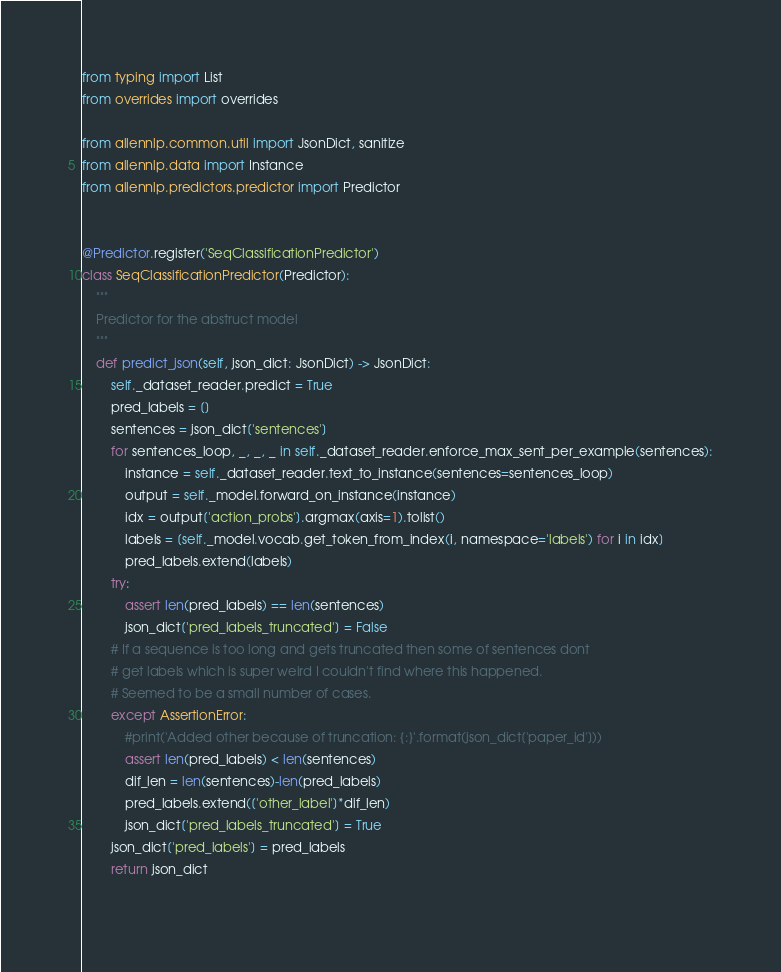<code> <loc_0><loc_0><loc_500><loc_500><_Python_>from typing import List
from overrides import overrides

from allennlp.common.util import JsonDict, sanitize
from allennlp.data import Instance
from allennlp.predictors.predictor import Predictor


@Predictor.register('SeqClassificationPredictor')
class SeqClassificationPredictor(Predictor):
    """
    Predictor for the abstruct model
    """
    def predict_json(self, json_dict: JsonDict) -> JsonDict:
        self._dataset_reader.predict = True
        pred_labels = []
        sentences = json_dict['sentences']
        for sentences_loop, _, _, _ in self._dataset_reader.enforce_max_sent_per_example(sentences):
            instance = self._dataset_reader.text_to_instance(sentences=sentences_loop)
            output = self._model.forward_on_instance(instance)
            idx = output['action_probs'].argmax(axis=1).tolist()
            labels = [self._model.vocab.get_token_from_index(i, namespace='labels') for i in idx]
            pred_labels.extend(labels)
        try:
            assert len(pred_labels) == len(sentences)
            json_dict['pred_labels_truncated'] = False
        # If a sequence is too long and gets truncated then some of sentences dont
        # get labels which is super weird I couldn't find where this happened.
        # Seemed to be a small number of cases.
        except AssertionError:
            #print('Added other because of truncation: {:}'.format(json_dict['paper_id']))
            assert len(pred_labels) < len(sentences)
            dif_len = len(sentences)-len(pred_labels)
            pred_labels.extend(['other_label']*dif_len)
            json_dict['pred_labels_truncated'] = True
        json_dict['pred_labels'] = pred_labels
        return json_dict
    
</code> 